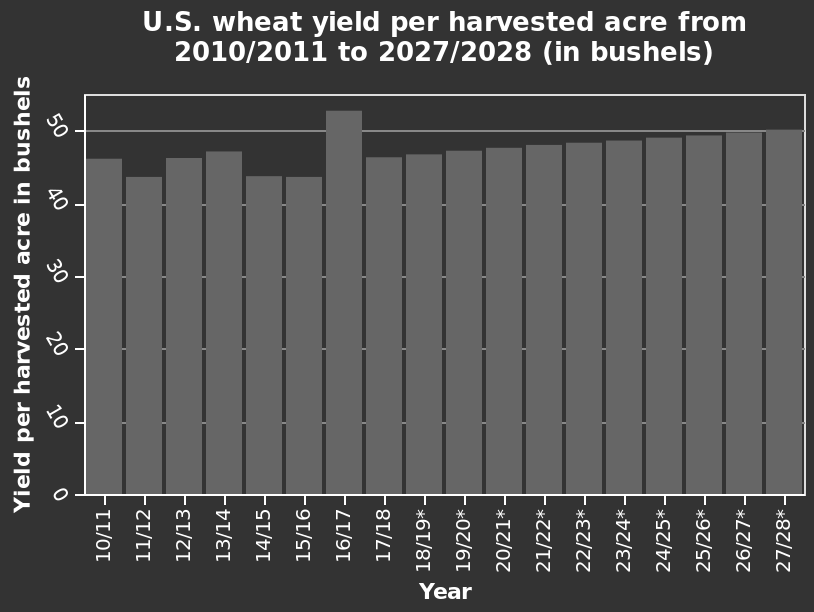<image>
What is the label of the y-axis on the bar chart?  The y-axis on the bar chart is labeled "Yield per harvested acre in bushels." What was the yield per harvested acre of U.S. wheat in the outlier year 2016/17? The yield per harvested acre of U.S. wheat in the outlier year 2016/17 was higher than the long-term trend. What is the unit of measurement for the data shown on the bar chart? The unit of measurement for the data shown on the bar chart is "bushels." 